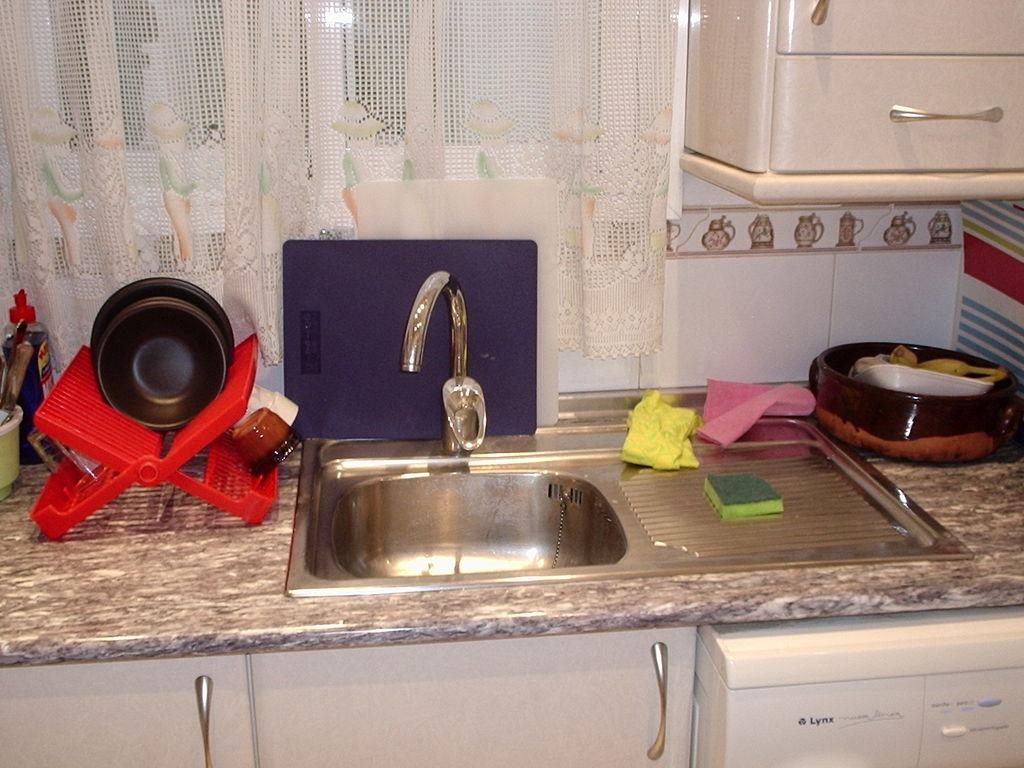<image>
Write a terse but informative summary of the picture. the word lynx that is on a dishwasher 